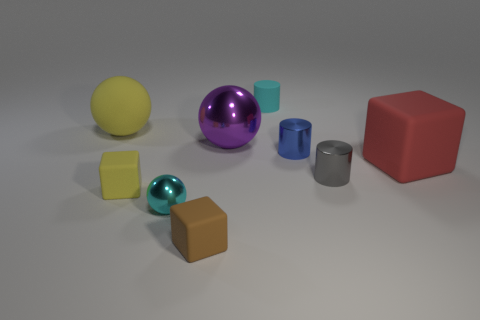What is the material of the small ball that is the same color as the rubber cylinder?
Your answer should be very brief. Metal. Is the color of the sphere in front of the red rubber cube the same as the matte cylinder?
Ensure brevity in your answer.  Yes. Is the number of yellow cubes less than the number of spheres?
Your answer should be very brief. Yes. What number of other things are there of the same color as the small rubber cylinder?
Your answer should be very brief. 1. Do the big object on the right side of the purple shiny ball and the gray thing have the same material?
Make the answer very short. No. What material is the cyan object that is in front of the tiny cyan matte object?
Offer a very short reply. Metal. What size is the cube in front of the tiny matte thing to the left of the brown matte cube?
Ensure brevity in your answer.  Small. Is there a small blue cylinder that has the same material as the small gray thing?
Make the answer very short. Yes. The tiny thing behind the yellow thing behind the big matte object on the right side of the tiny matte cylinder is what shape?
Make the answer very short. Cylinder. There is a shiny sphere that is in front of the big purple thing; does it have the same color as the tiny rubber object that is to the right of the brown object?
Your answer should be very brief. Yes. 